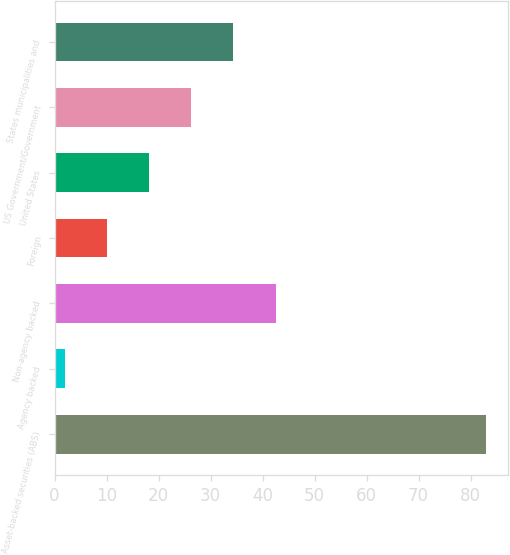Convert chart to OTSL. <chart><loc_0><loc_0><loc_500><loc_500><bar_chart><fcel>Asset-backed securities (ABS)<fcel>Agency backed<fcel>Non-agency backed<fcel>Foreign<fcel>United States<fcel>US Government/Government<fcel>States municipalities and<nl><fcel>83<fcel>2<fcel>42.5<fcel>10.1<fcel>18.2<fcel>26.3<fcel>34.4<nl></chart> 